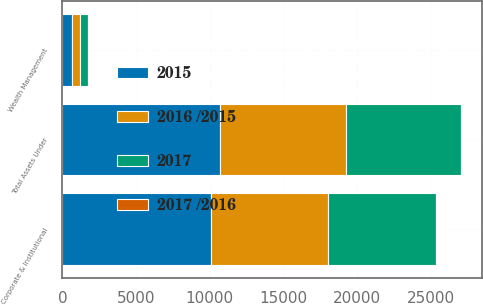<chart> <loc_0><loc_0><loc_500><loc_500><stacked_bar_chart><ecel><fcel>Corporate & Institutional<fcel>Wealth Management<fcel>Total Assets Under<nl><fcel>2015<fcel>10066.8<fcel>655.8<fcel>10722.6<nl><fcel>2016 /2015<fcel>7987<fcel>554.3<fcel>8541.3<nl><fcel>2017<fcel>7279.7<fcel>517.3<fcel>7797<nl><fcel>2017 /2016<fcel>26<fcel>18<fcel>26<nl></chart> 